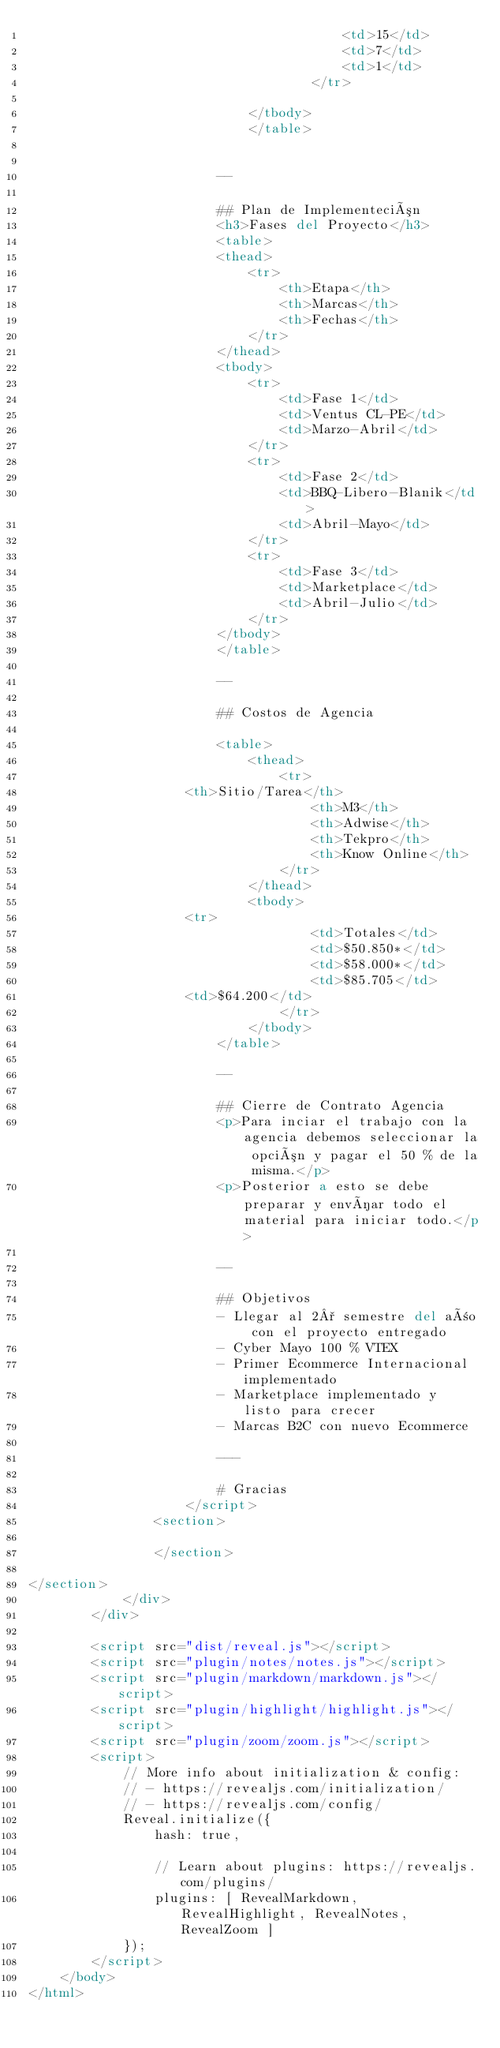<code> <loc_0><loc_0><loc_500><loc_500><_HTML_>                                        <td>15</td>
                                        <td>7</td>
                                        <td>1</td>
                                    </tr>
                                
                            </tbody>
                            </table>
                       

                        --

                        ## Plan de Implementeción 
                        <h3>Fases del Proyecto</h3>
					    <table>
						<thead>
							<tr>
								<th>Etapa</th>
								<th>Marcas</th>
								<th>Fechas</th>
							</tr>
						</thead>
						<tbody>
							<tr>
								<td>Fase 1</td>
								<td>Ventus CL-PE</td>
								<td>Marzo-Abril</td>
							</tr>
							<tr>
								<td>Fase 2</td>
								<td>BBQ-Libero-Blanik</td>
								<td>Abril-Mayo</td>
							</tr>
							<tr>
								<td>Fase 3</td>
								<td>Marketplace</td>
								<td>Abril-Julio</td>
							</tr>
						</tbody>
					    </table>

                        --

                        ## Costos de Agencia
                        
                        <table>
                            <thead>
                                <tr>
				    <th>Sitio/Tarea</th>
                                    <th>M3</th>
                                    <th>Adwise</th>
                                    <th>Tekpro</th>
                                    <th>Know Online</th>
                                </tr>
                            </thead>
                            <tbody>
			    	<tr>
                                    <td>Totales</td>
                                    <td>$50.850*</td>
                                    <td>$58.000*</td>
                                    <td>$85.705</td>
				    <td>$64.200</td>
                                </tr>
                            </tbody>
                        </table>

                        --

                        ## Cierre de Contrato Agencia
                        <p>Para inciar el trabajo con la agencia debemos seleccionar la opción y pagar el 50 % de la misma.</p>
                        <p>Posterior a esto se debe preparar y envíar todo el material para iniciar todo.</p>

                        --

                        ## Objetivos
                        - Llegar al 2° semestre del año con el proyecto entregado
                        - Cyber Mayo 100 % VTEX
                        - Primer Ecommerce Internacional implementado
                        - Marketplace implementado y listo para crecer
                        - Marcas B2C con nuevo Ecommerce

                        ---

                        # Gracias
                    </script>
				<section>

				</section>

</section>
            </div>
        </div>

		<script src="dist/reveal.js"></script>
		<script src="plugin/notes/notes.js"></script>
		<script src="plugin/markdown/markdown.js"></script>
		<script src="plugin/highlight/highlight.js"></script>
		<script src="plugin/zoom/zoom.js"></script>
		<script>
			// More info about initialization & config:
			// - https://revealjs.com/initialization/
			// - https://revealjs.com/config/
			Reveal.initialize({
				hash: true,

				// Learn about plugins: https://revealjs.com/plugins/
				plugins: [ RevealMarkdown, RevealHighlight, RevealNotes, RevealZoom ]
			});
		</script>
	</body>
</html>
</code> 